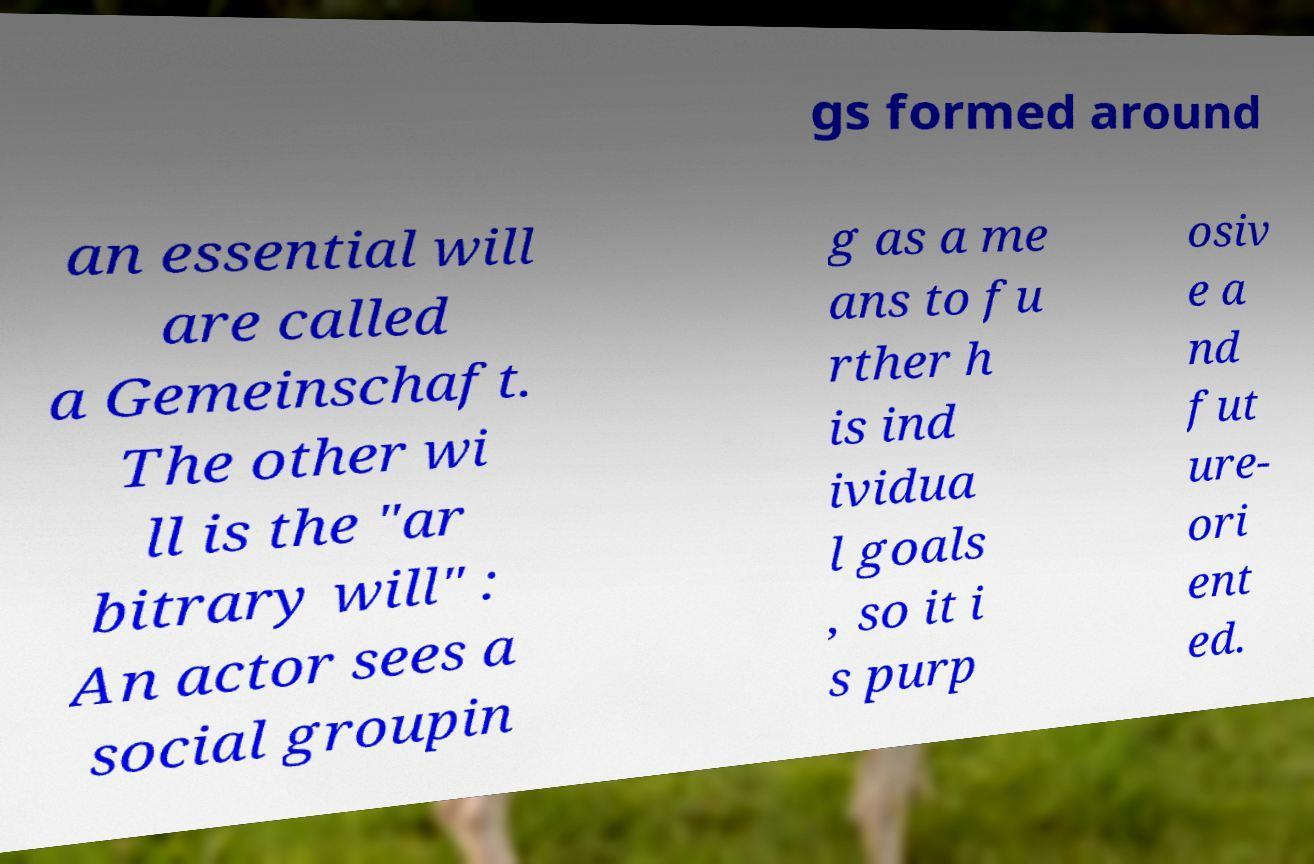Please read and relay the text visible in this image. What does it say? gs formed around an essential will are called a Gemeinschaft. The other wi ll is the "ar bitrary will" : An actor sees a social groupin g as a me ans to fu rther h is ind ividua l goals , so it i s purp osiv e a nd fut ure- ori ent ed. 